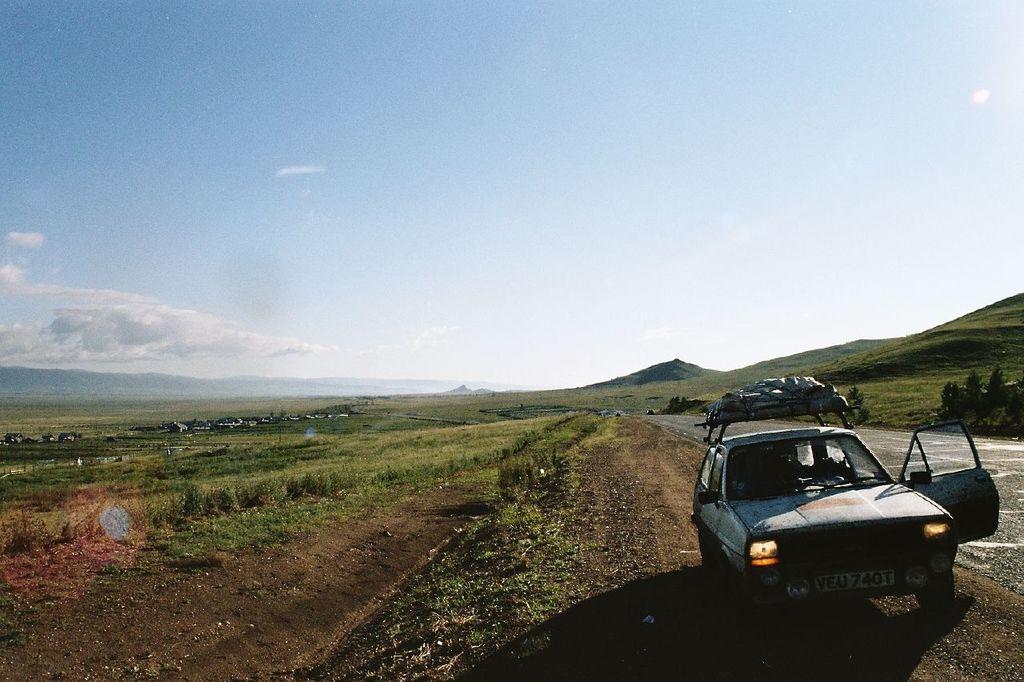Can you describe this image briefly? In this image there is a car, plants, grass, trees, houses, hills, and in the background there is sky. 